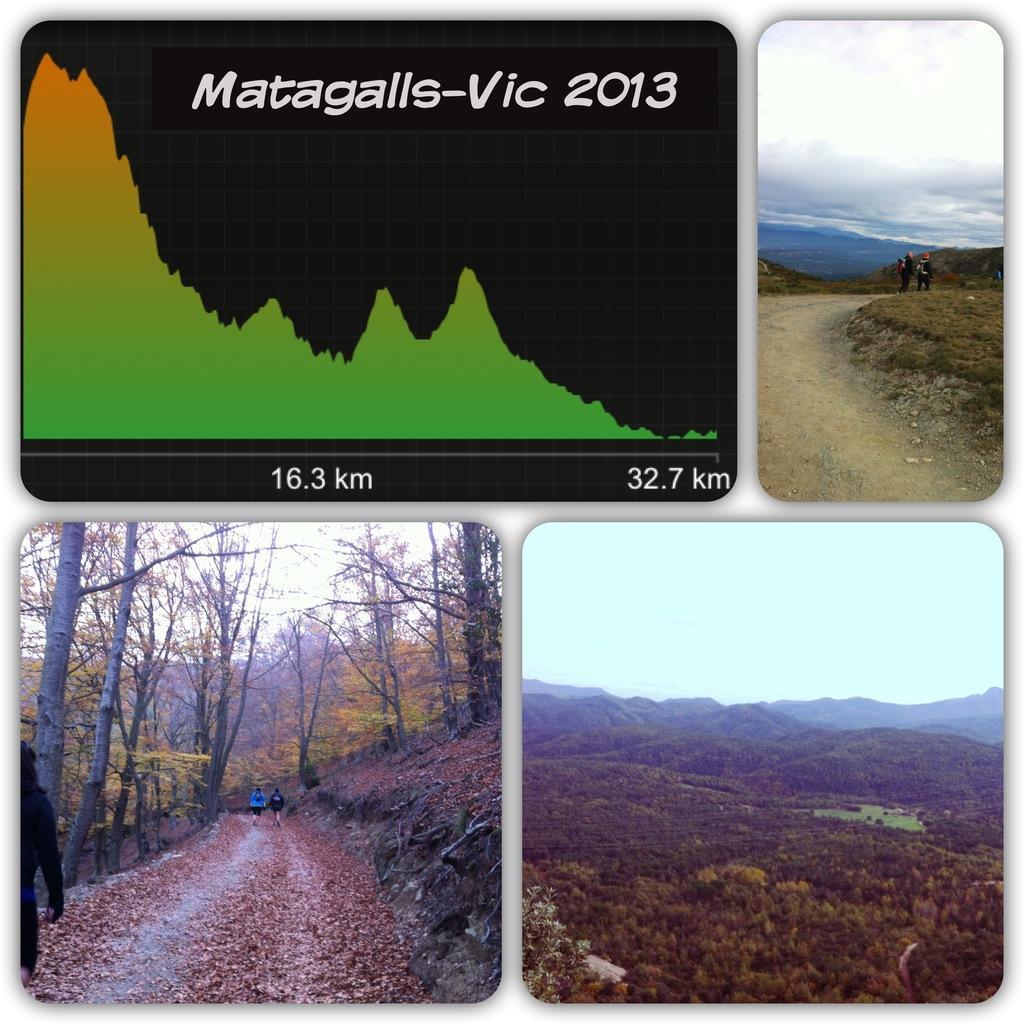How would you summarize this image in a sentence or two? In this picture we can see some collage of scenery images, among the four images, we can see few people are walking in two images. 